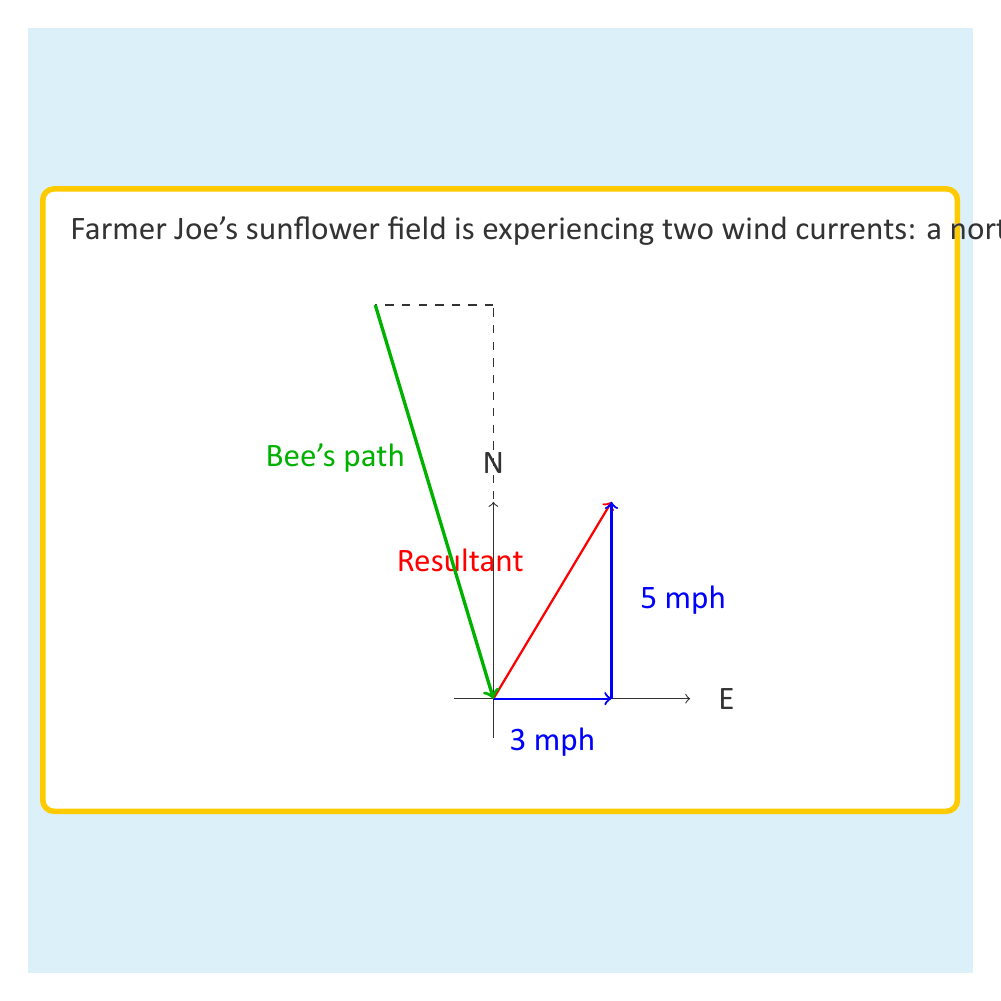Teach me how to tackle this problem. Let's approach this step-by-step:

1) We need to use vector addition to find the resultant wind velocity.

2) The northerly wind can be represented as a vector $\vec{v_1} = 5\hat{j}$ (5 units in the y-direction).

3) The easterly wind can be represented as a vector $\vec{v_2} = 3\hat{i}$ (3 units in the x-direction).

4) The resultant wind vector $\vec{R}$ is the sum of these two vectors:

   $\vec{R} = \vec{v_1} + \vec{v_2} = 3\hat{i} + 5\hat{j}$

5) To find the magnitude of this resultant vector, we use the Pythagorean theorem:

   $|\vec{R}| = \sqrt{3^2 + 5^2} = \sqrt{34} \approx 5.83$ mph

6) The direction of the resultant wind can be found using the arctangent function:

   $\theta = \tan^{-1}(\frac{5}{3}) \approx 59.04°$ from East

7) Now, the bees are flying against this wind. Their velocity vector will be the difference between their normal flying vector and the wind vector.

8) The bees' normal flying vector in still air is $10\hat{i}$ (assuming they're flying due East towards the sunflowers).

9) The bees' effective velocity vector $\vec{v_b}$ is:

   $\vec{v_b} = 10\hat{i} - (3\hat{i} + 5\hat{j}) = 7\hat{i} - 5\hat{j}$

10) The magnitude of this vector (the bees' effective speed) is:

    $|\vec{v_b}| = \sqrt{7^2 + (-5)^2} = \sqrt{74} \approx 8.60$ mph

11) The direction of the bees' flight relative to due East is:

    $\theta_b = \tan^{-1}(\frac{-5}{7}) \approx -35.54°$ (or about 35.54° South of East)
Answer: The bees' effective speed is approximately 8.60 mph, flying at an angle of about 35.54° South of East. 